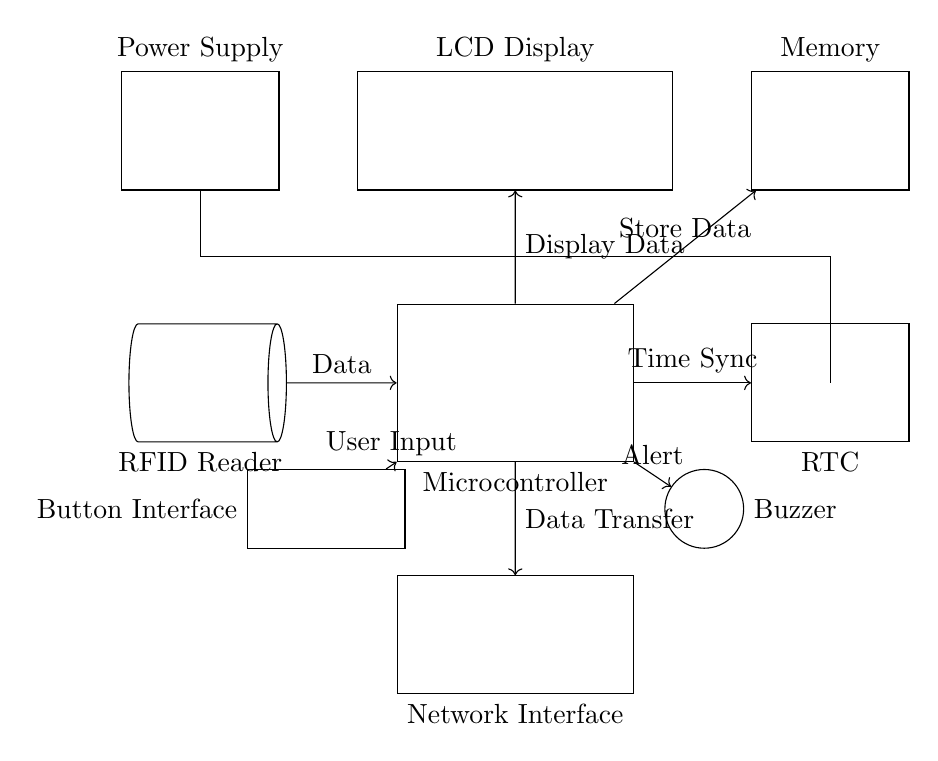What component reads the employee data? The RFID Reader is the component responsible for reading employee data, as indicated in the diagram by its label and position.
Answer: RFID Reader What does the microcontroller connect to for data synchronization? The microcontroller connects to the Real-Time Clock (RTC) for data synchronization, which ensures accurate timekeeping for attendance logging.
Answer: Real-Time Clock What component provides notifications to users? The Buzzer is the component that provides notifications to users, as indicated by its connection to the microcontroller for alert signals.
Answer: Buzzer How many primary components are aligned horizontally in the diagram? There are four primary components aligned horizontally in the diagram: the RFID Reader, Microcontroller, RTC, and Power Supply.
Answer: Four What type of interface does the employee use to provide inputs? The Button Interface is used by employees to provide inputs, allowing them to interact with the system for attendance purposes.
Answer: Button Interface Which component is responsible for displaying data? The LCD Display is responsible for showing data to the user, receiving display information from the microcontroller as shown in the connections.
Answer: LCD Display Explain the data flow from the RFID Reader to the Network Interface. The data flow starts from the RFID Reader, which sends data to the Microcontroller. The Microcontroller processes the data and then sends it to the Network Interface for data transfer. This ensures that employee attendance data can be communicated over a network.
Answer: Microcontroller 